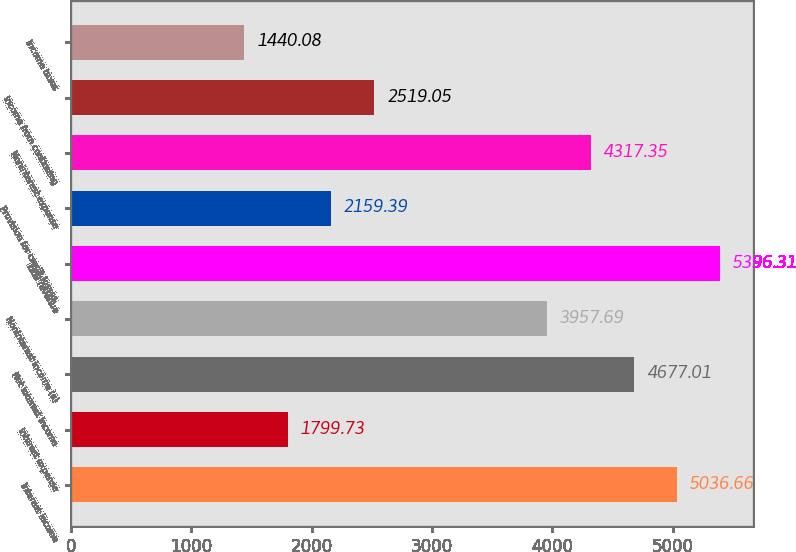<chart> <loc_0><loc_0><loc_500><loc_500><bar_chart><fcel>Interest income<fcel>Interest expense<fcel>Net interest income<fcel>Noninterest income (a)<fcel>Total revenue<fcel>Provision for credit losses<fcel>Noninterest expense<fcel>Income from continuing<fcel>Income taxes<nl><fcel>5036.66<fcel>1799.73<fcel>4677.01<fcel>3957.69<fcel>5396.31<fcel>2159.39<fcel>4317.35<fcel>2519.05<fcel>1440.08<nl></chart> 